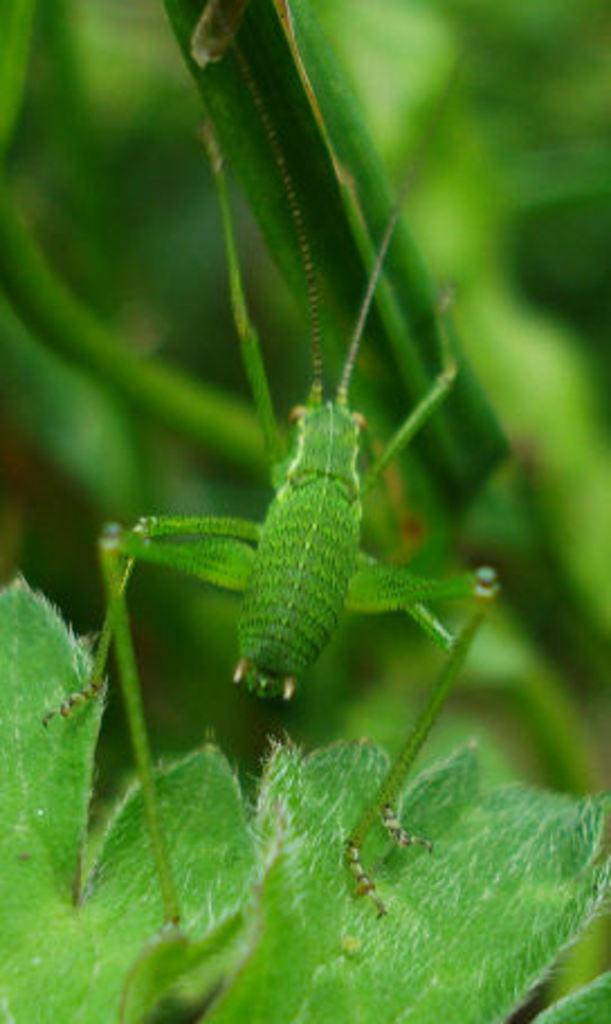What type of vegetation can be seen in the image? There are leaves in the image. What else is present in the image besides the leaves? There is an insect in the middle of the image. How many chairs are visible in the image? There are no chairs present in the image. What type of bike can be seen in the image? There is no bike present in the image. 